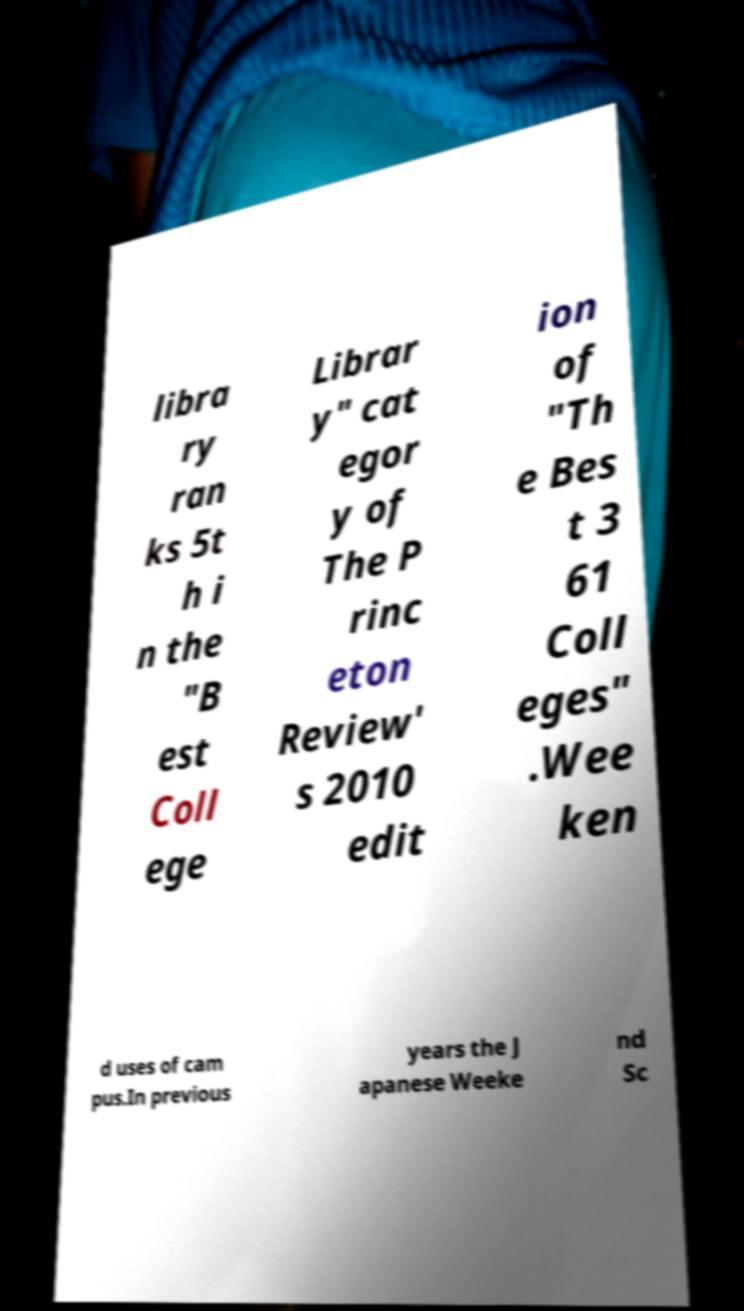Please read and relay the text visible in this image. What does it say? libra ry ran ks 5t h i n the "B est Coll ege Librar y" cat egor y of The P rinc eton Review' s 2010 edit ion of "Th e Bes t 3 61 Coll eges" .Wee ken d uses of cam pus.In previous years the J apanese Weeke nd Sc 